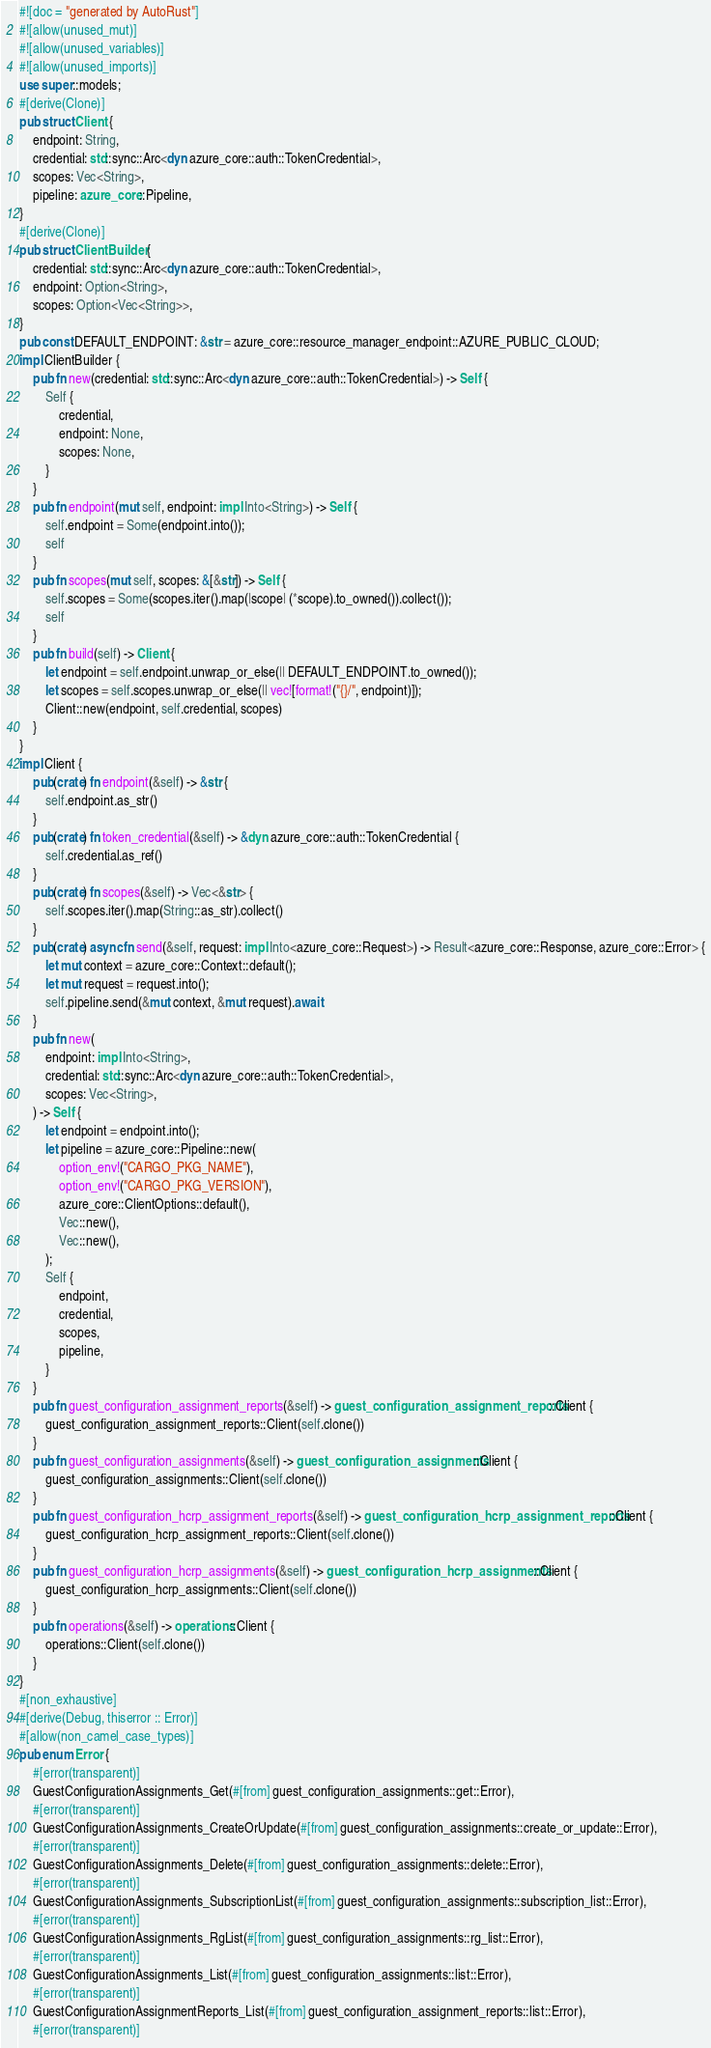Convert code to text. <code><loc_0><loc_0><loc_500><loc_500><_Rust_>#![doc = "generated by AutoRust"]
#![allow(unused_mut)]
#![allow(unused_variables)]
#![allow(unused_imports)]
use super::models;
#[derive(Clone)]
pub struct Client {
    endpoint: String,
    credential: std::sync::Arc<dyn azure_core::auth::TokenCredential>,
    scopes: Vec<String>,
    pipeline: azure_core::Pipeline,
}
#[derive(Clone)]
pub struct ClientBuilder {
    credential: std::sync::Arc<dyn azure_core::auth::TokenCredential>,
    endpoint: Option<String>,
    scopes: Option<Vec<String>>,
}
pub const DEFAULT_ENDPOINT: &str = azure_core::resource_manager_endpoint::AZURE_PUBLIC_CLOUD;
impl ClientBuilder {
    pub fn new(credential: std::sync::Arc<dyn azure_core::auth::TokenCredential>) -> Self {
        Self {
            credential,
            endpoint: None,
            scopes: None,
        }
    }
    pub fn endpoint(mut self, endpoint: impl Into<String>) -> Self {
        self.endpoint = Some(endpoint.into());
        self
    }
    pub fn scopes(mut self, scopes: &[&str]) -> Self {
        self.scopes = Some(scopes.iter().map(|scope| (*scope).to_owned()).collect());
        self
    }
    pub fn build(self) -> Client {
        let endpoint = self.endpoint.unwrap_or_else(|| DEFAULT_ENDPOINT.to_owned());
        let scopes = self.scopes.unwrap_or_else(|| vec![format!("{}/", endpoint)]);
        Client::new(endpoint, self.credential, scopes)
    }
}
impl Client {
    pub(crate) fn endpoint(&self) -> &str {
        self.endpoint.as_str()
    }
    pub(crate) fn token_credential(&self) -> &dyn azure_core::auth::TokenCredential {
        self.credential.as_ref()
    }
    pub(crate) fn scopes(&self) -> Vec<&str> {
        self.scopes.iter().map(String::as_str).collect()
    }
    pub(crate) async fn send(&self, request: impl Into<azure_core::Request>) -> Result<azure_core::Response, azure_core::Error> {
        let mut context = azure_core::Context::default();
        let mut request = request.into();
        self.pipeline.send(&mut context, &mut request).await
    }
    pub fn new(
        endpoint: impl Into<String>,
        credential: std::sync::Arc<dyn azure_core::auth::TokenCredential>,
        scopes: Vec<String>,
    ) -> Self {
        let endpoint = endpoint.into();
        let pipeline = azure_core::Pipeline::new(
            option_env!("CARGO_PKG_NAME"),
            option_env!("CARGO_PKG_VERSION"),
            azure_core::ClientOptions::default(),
            Vec::new(),
            Vec::new(),
        );
        Self {
            endpoint,
            credential,
            scopes,
            pipeline,
        }
    }
    pub fn guest_configuration_assignment_reports(&self) -> guest_configuration_assignment_reports::Client {
        guest_configuration_assignment_reports::Client(self.clone())
    }
    pub fn guest_configuration_assignments(&self) -> guest_configuration_assignments::Client {
        guest_configuration_assignments::Client(self.clone())
    }
    pub fn guest_configuration_hcrp_assignment_reports(&self) -> guest_configuration_hcrp_assignment_reports::Client {
        guest_configuration_hcrp_assignment_reports::Client(self.clone())
    }
    pub fn guest_configuration_hcrp_assignments(&self) -> guest_configuration_hcrp_assignments::Client {
        guest_configuration_hcrp_assignments::Client(self.clone())
    }
    pub fn operations(&self) -> operations::Client {
        operations::Client(self.clone())
    }
}
#[non_exhaustive]
#[derive(Debug, thiserror :: Error)]
#[allow(non_camel_case_types)]
pub enum Error {
    #[error(transparent)]
    GuestConfigurationAssignments_Get(#[from] guest_configuration_assignments::get::Error),
    #[error(transparent)]
    GuestConfigurationAssignments_CreateOrUpdate(#[from] guest_configuration_assignments::create_or_update::Error),
    #[error(transparent)]
    GuestConfigurationAssignments_Delete(#[from] guest_configuration_assignments::delete::Error),
    #[error(transparent)]
    GuestConfigurationAssignments_SubscriptionList(#[from] guest_configuration_assignments::subscription_list::Error),
    #[error(transparent)]
    GuestConfigurationAssignments_RgList(#[from] guest_configuration_assignments::rg_list::Error),
    #[error(transparent)]
    GuestConfigurationAssignments_List(#[from] guest_configuration_assignments::list::Error),
    #[error(transparent)]
    GuestConfigurationAssignmentReports_List(#[from] guest_configuration_assignment_reports::list::Error),
    #[error(transparent)]</code> 